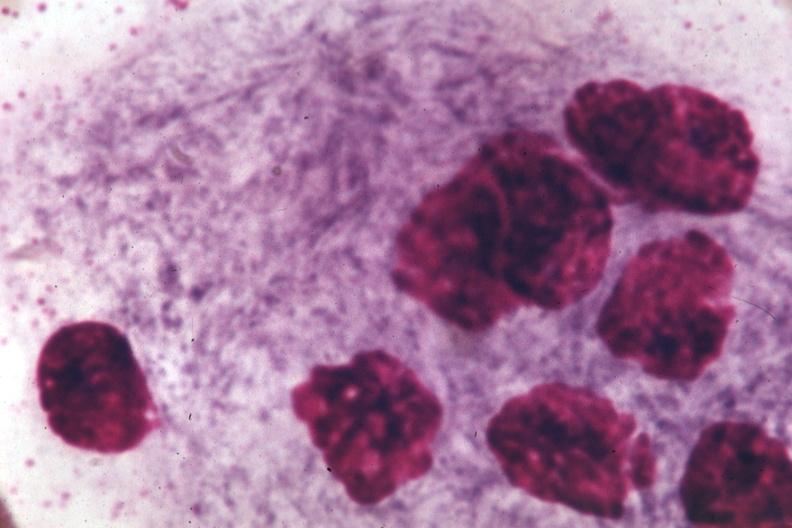does another fiber other frame show oil immersion wrights typical cell?
Answer the question using a single word or phrase. No 